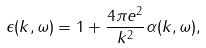<formula> <loc_0><loc_0><loc_500><loc_500>\epsilon ( k , \omega ) = 1 + \frac { 4 \pi e ^ { 2 } } { k ^ { 2 } } \alpha ( k , \omega ) ,</formula> 